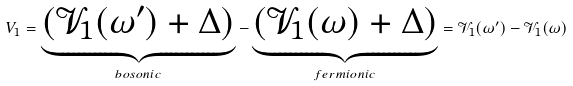Convert formula to latex. <formula><loc_0><loc_0><loc_500><loc_500>V _ { 1 } = \underbrace { ( { \mathcal { V } } _ { 1 } ( \omega ^ { \prime } ) + \Delta ) } _ { b o s o n i c } - \underbrace { ( { \mathcal { V } } _ { 1 } ( \omega ) + \Delta ) } _ { f e r m i o n i c } = { \mathcal { V } } _ { 1 } ( \omega ^ { \prime } ) - { \mathcal { V } } _ { 1 } ( \omega )</formula> 